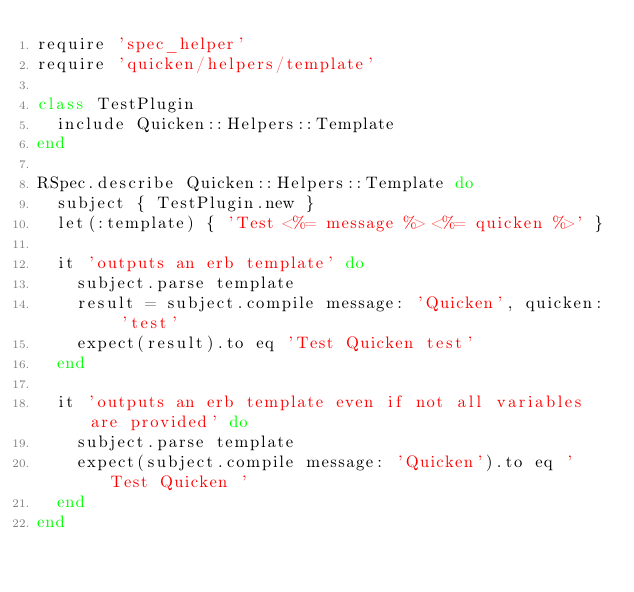Convert code to text. <code><loc_0><loc_0><loc_500><loc_500><_Ruby_>require 'spec_helper'
require 'quicken/helpers/template'

class TestPlugin
  include Quicken::Helpers::Template
end

RSpec.describe Quicken::Helpers::Template do
  subject { TestPlugin.new }
  let(:template) { 'Test <%= message %> <%= quicken %>' }

  it 'outputs an erb template' do
    subject.parse template
    result = subject.compile message: 'Quicken', quicken: 'test'
    expect(result).to eq 'Test Quicken test'
  end

  it 'outputs an erb template even if not all variables are provided' do
    subject.parse template
    expect(subject.compile message: 'Quicken').to eq 'Test Quicken '
  end
end</code> 